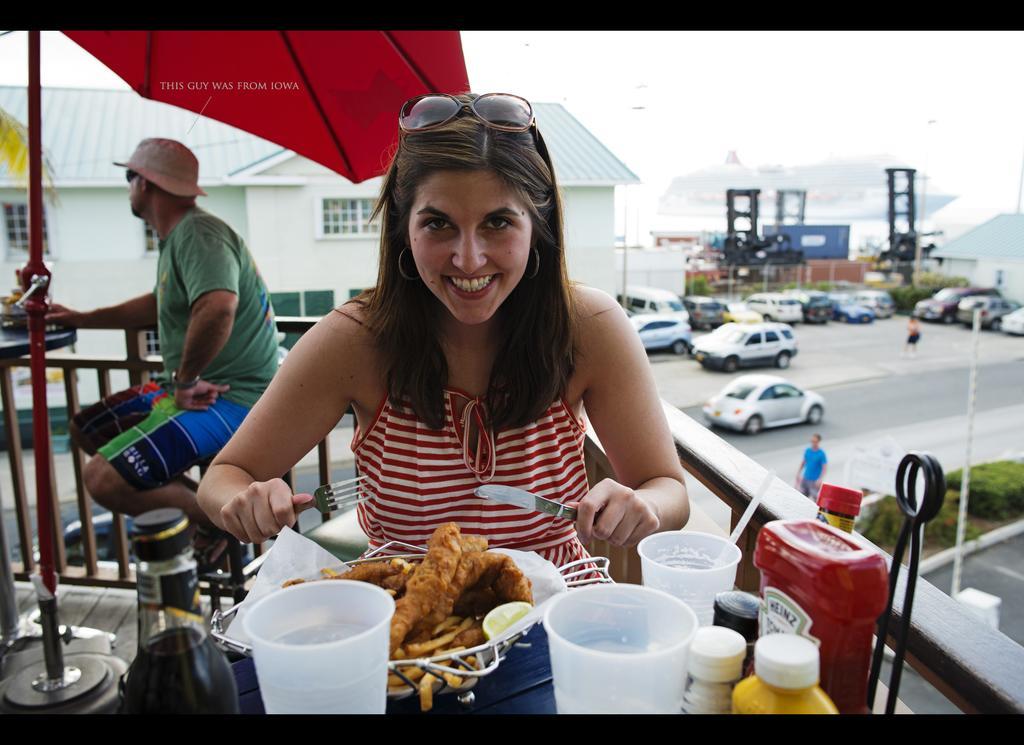Please provide a concise description of this image. In the picture we can see a woman sitting on the stool near the table on it we can see some food items and beside it we can see some glasses and some bottles and she is holding a fork and a spoon and behind her we can see another man sitting on the stool near the table and near him we can see an umbrella with a pole and behind him we can see a railing and behind it we can see a building and near to it we can see some cars are parked and a man standing on the road and near to him we can see some plants and in the background we can see a ship in the water. 